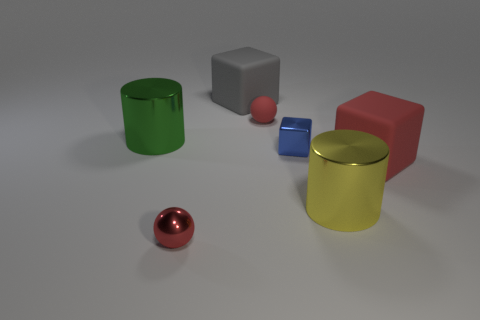How many other objects are the same material as the tiny blue block?
Provide a short and direct response. 3. Do the red object left of the gray matte object and the large cylinder in front of the blue metal block have the same material?
Ensure brevity in your answer.  Yes. What is the material of the small blue cube?
Make the answer very short. Metal. How many tiny blue shiny objects are the same shape as the big gray matte thing?
Offer a very short reply. 1. There is a large cube that is the same color as the small matte object; what material is it?
Make the answer very short. Rubber. What is the color of the small metal thing that is behind the ball in front of the cylinder that is behind the red rubber cube?
Your answer should be compact. Blue. What number of big things are rubber balls or yellow matte cylinders?
Provide a short and direct response. 0. Are there the same number of large yellow things behind the tiny metal cube and yellow spheres?
Offer a terse response. Yes. Are there any big green cylinders left of the small blue shiny block?
Provide a short and direct response. Yes. What number of rubber things are large things or big yellow objects?
Make the answer very short. 2. 